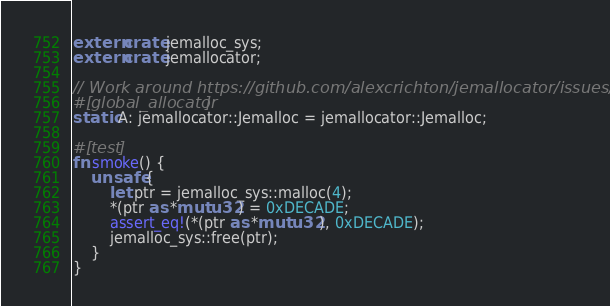Convert code to text. <code><loc_0><loc_0><loc_500><loc_500><_Rust_>extern crate jemalloc_sys;
extern crate jemallocator;

// Work around https://github.com/alexcrichton/jemallocator/issues/19
#[global_allocator]
static A: jemallocator::Jemalloc = jemallocator::Jemalloc;

#[test]
fn smoke() {
    unsafe {
        let ptr = jemalloc_sys::malloc(4);
        *(ptr as *mut u32) = 0xDECADE;
        assert_eq!(*(ptr as *mut u32), 0xDECADE);
        jemalloc_sys::free(ptr);
    }
}
</code> 